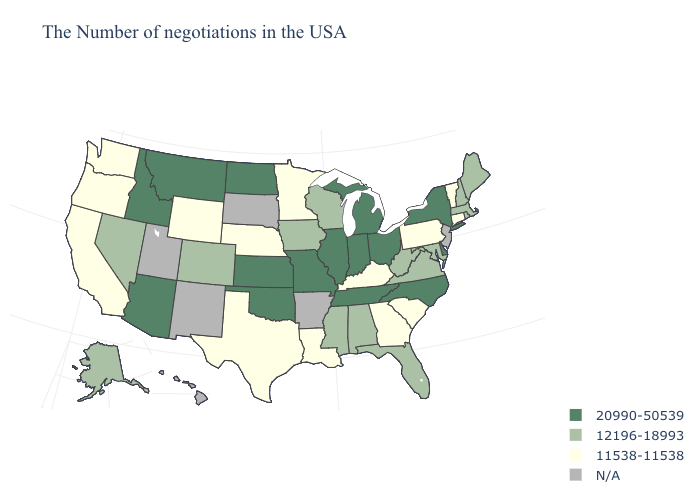What is the value of Alaska?
Give a very brief answer. 12196-18993. What is the value of Connecticut?
Write a very short answer. 11538-11538. Does Connecticut have the highest value in the Northeast?
Quick response, please. No. Does Wyoming have the lowest value in the USA?
Write a very short answer. Yes. What is the value of Kansas?
Be succinct. 20990-50539. Name the states that have a value in the range 11538-11538?
Quick response, please. Vermont, Connecticut, Pennsylvania, South Carolina, Georgia, Kentucky, Louisiana, Minnesota, Nebraska, Texas, Wyoming, California, Washington, Oregon. Name the states that have a value in the range 11538-11538?
Answer briefly. Vermont, Connecticut, Pennsylvania, South Carolina, Georgia, Kentucky, Louisiana, Minnesota, Nebraska, Texas, Wyoming, California, Washington, Oregon. Name the states that have a value in the range N/A?
Concise answer only. New Jersey, Arkansas, South Dakota, New Mexico, Utah, Hawaii. Which states have the lowest value in the USA?
Be succinct. Vermont, Connecticut, Pennsylvania, South Carolina, Georgia, Kentucky, Louisiana, Minnesota, Nebraska, Texas, Wyoming, California, Washington, Oregon. Name the states that have a value in the range 12196-18993?
Give a very brief answer. Maine, Massachusetts, Rhode Island, New Hampshire, Maryland, Virginia, West Virginia, Florida, Alabama, Wisconsin, Mississippi, Iowa, Colorado, Nevada, Alaska. Among the states that border New Hampshire , which have the highest value?
Concise answer only. Maine, Massachusetts. What is the value of New Mexico?
Concise answer only. N/A. Name the states that have a value in the range N/A?
Concise answer only. New Jersey, Arkansas, South Dakota, New Mexico, Utah, Hawaii. 